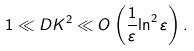Convert formula to latex. <formula><loc_0><loc_0><loc_500><loc_500>1 \ll D K ^ { 2 } \ll O \left ( \frac { 1 } { \varepsilon } { \ln ^ { 2 } { \varepsilon } } \right ) .</formula> 